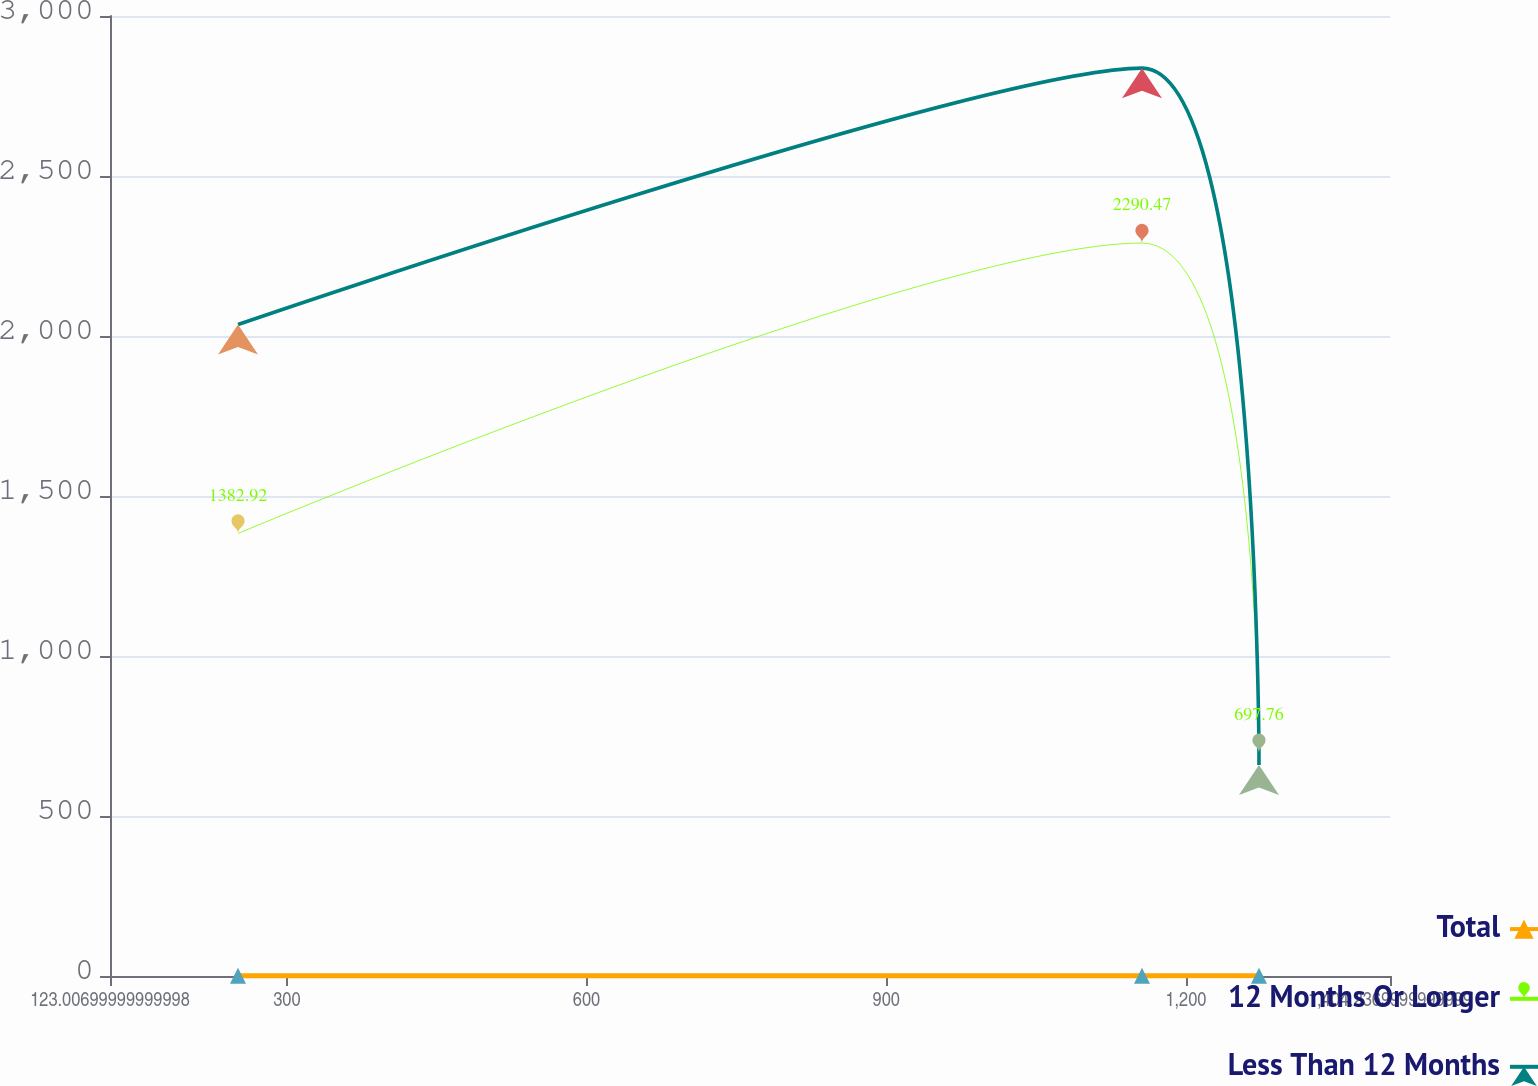Convert chart. <chart><loc_0><loc_0><loc_500><loc_500><line_chart><ecel><fcel>Total<fcel>12 Months Or Longer<fcel>Less Than 12 Months<nl><fcel>251.13<fcel>0.57<fcel>1382.92<fcel>2035.87<nl><fcel>1155.97<fcel>0.47<fcel>2290.47<fcel>2837<nl><fcel>1273.1<fcel>0.77<fcel>697.76<fcel>659.68<nl><fcel>1415.23<fcel>0.67<fcel>2.98<fcel>32.32<nl><fcel>1532.36<fcel>1.48<fcel>2063.22<fcel>1755.4<nl></chart> 